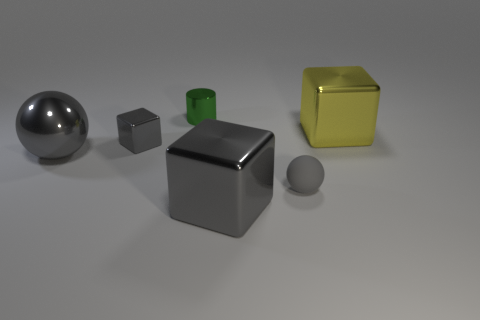Is there anything else that is the same material as the small gray sphere?
Your response must be concise. No. There is another ball that is the same color as the large metallic ball; what is its material?
Make the answer very short. Rubber. How many other objects are there of the same color as the metal ball?
Your answer should be very brief. 3. Is there a object that has the same color as the shiny sphere?
Ensure brevity in your answer.  Yes. What number of objects are either big things on the left side of the big yellow cube or metallic blocks left of the small rubber thing?
Make the answer very short. 3. How many metallic things have the same shape as the gray matte object?
Your answer should be very brief. 1. There is a gray thing that is both in front of the tiny gray shiny cube and left of the small green thing; what material is it?
Your response must be concise. Metal. There is a green metallic cylinder; how many large gray metallic blocks are in front of it?
Offer a terse response. 1. How many gray metallic blocks are there?
Give a very brief answer. 2. Does the rubber thing have the same size as the green object?
Keep it short and to the point. Yes. 